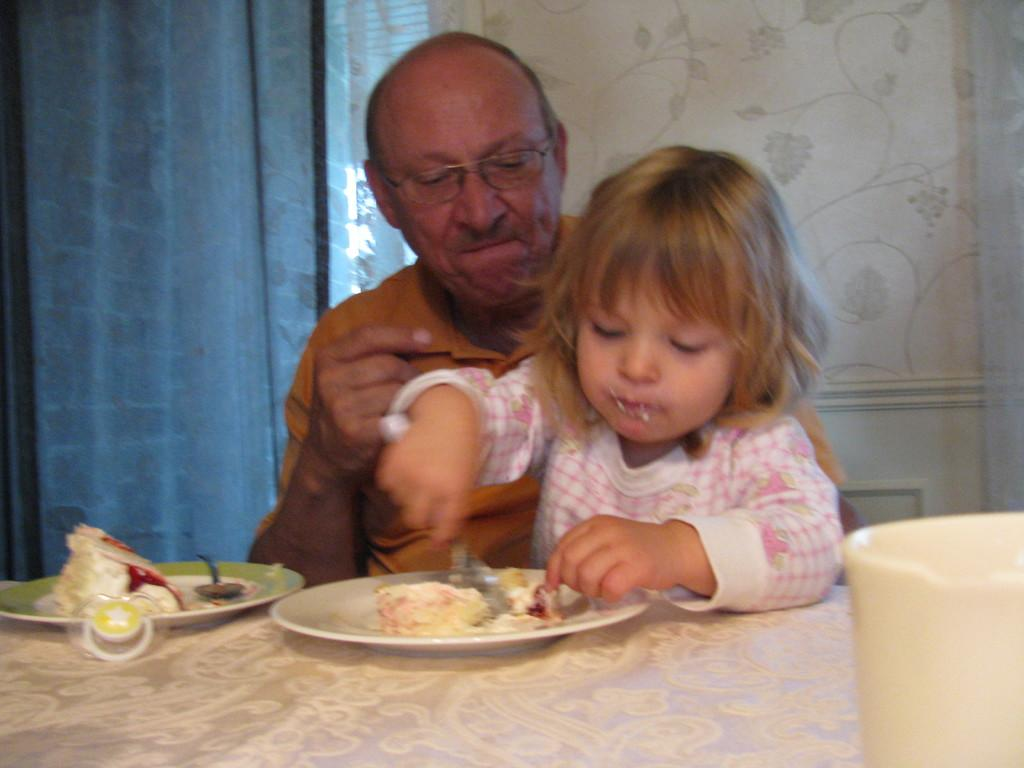How many people are in the image? There are two persons in the foreground of the image. What is located in the foreground of the image with the people? There is a table in the foreground of the image. What can be found on the table? Plates, food items, and a cup are present on the table. What can be seen in the background of the image? There is a wall and a curtain in the background of the image. Where was the image taken? The image was taken in a hall. What type of clam is being served on the table in the image? There is no clam present on the table in the image. What rule is being enforced by the people in the image? There is no indication of any rule being enforced in the image. Is eggnog being consumed by the people in the image? There is no eggnog visible in the image, and it cannot be determined if it is being consumed. 